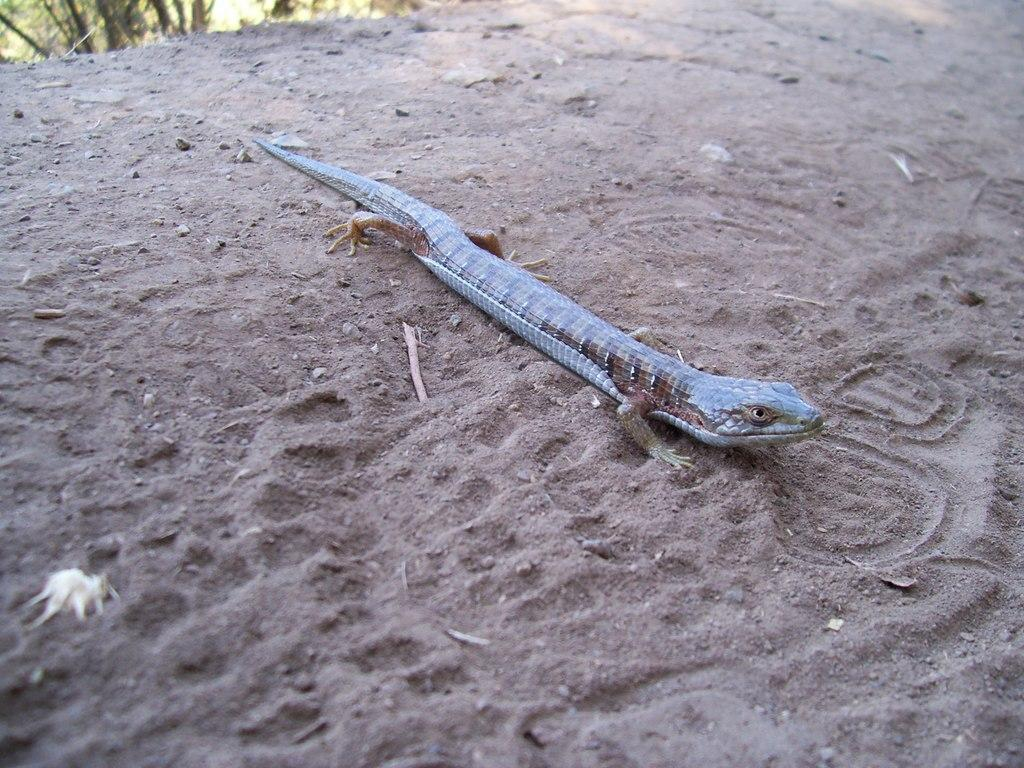What type of animal is in the picture? There is a reptile in the picture. Where is the reptile located in the image? The reptile is on the ground. What colors can be seen on the reptile? The reptile is black, brown, and grey in color. What type of eye can be seen on the carriage in the image? There is no carriage or eye present in the image; it features a reptile on the ground. 